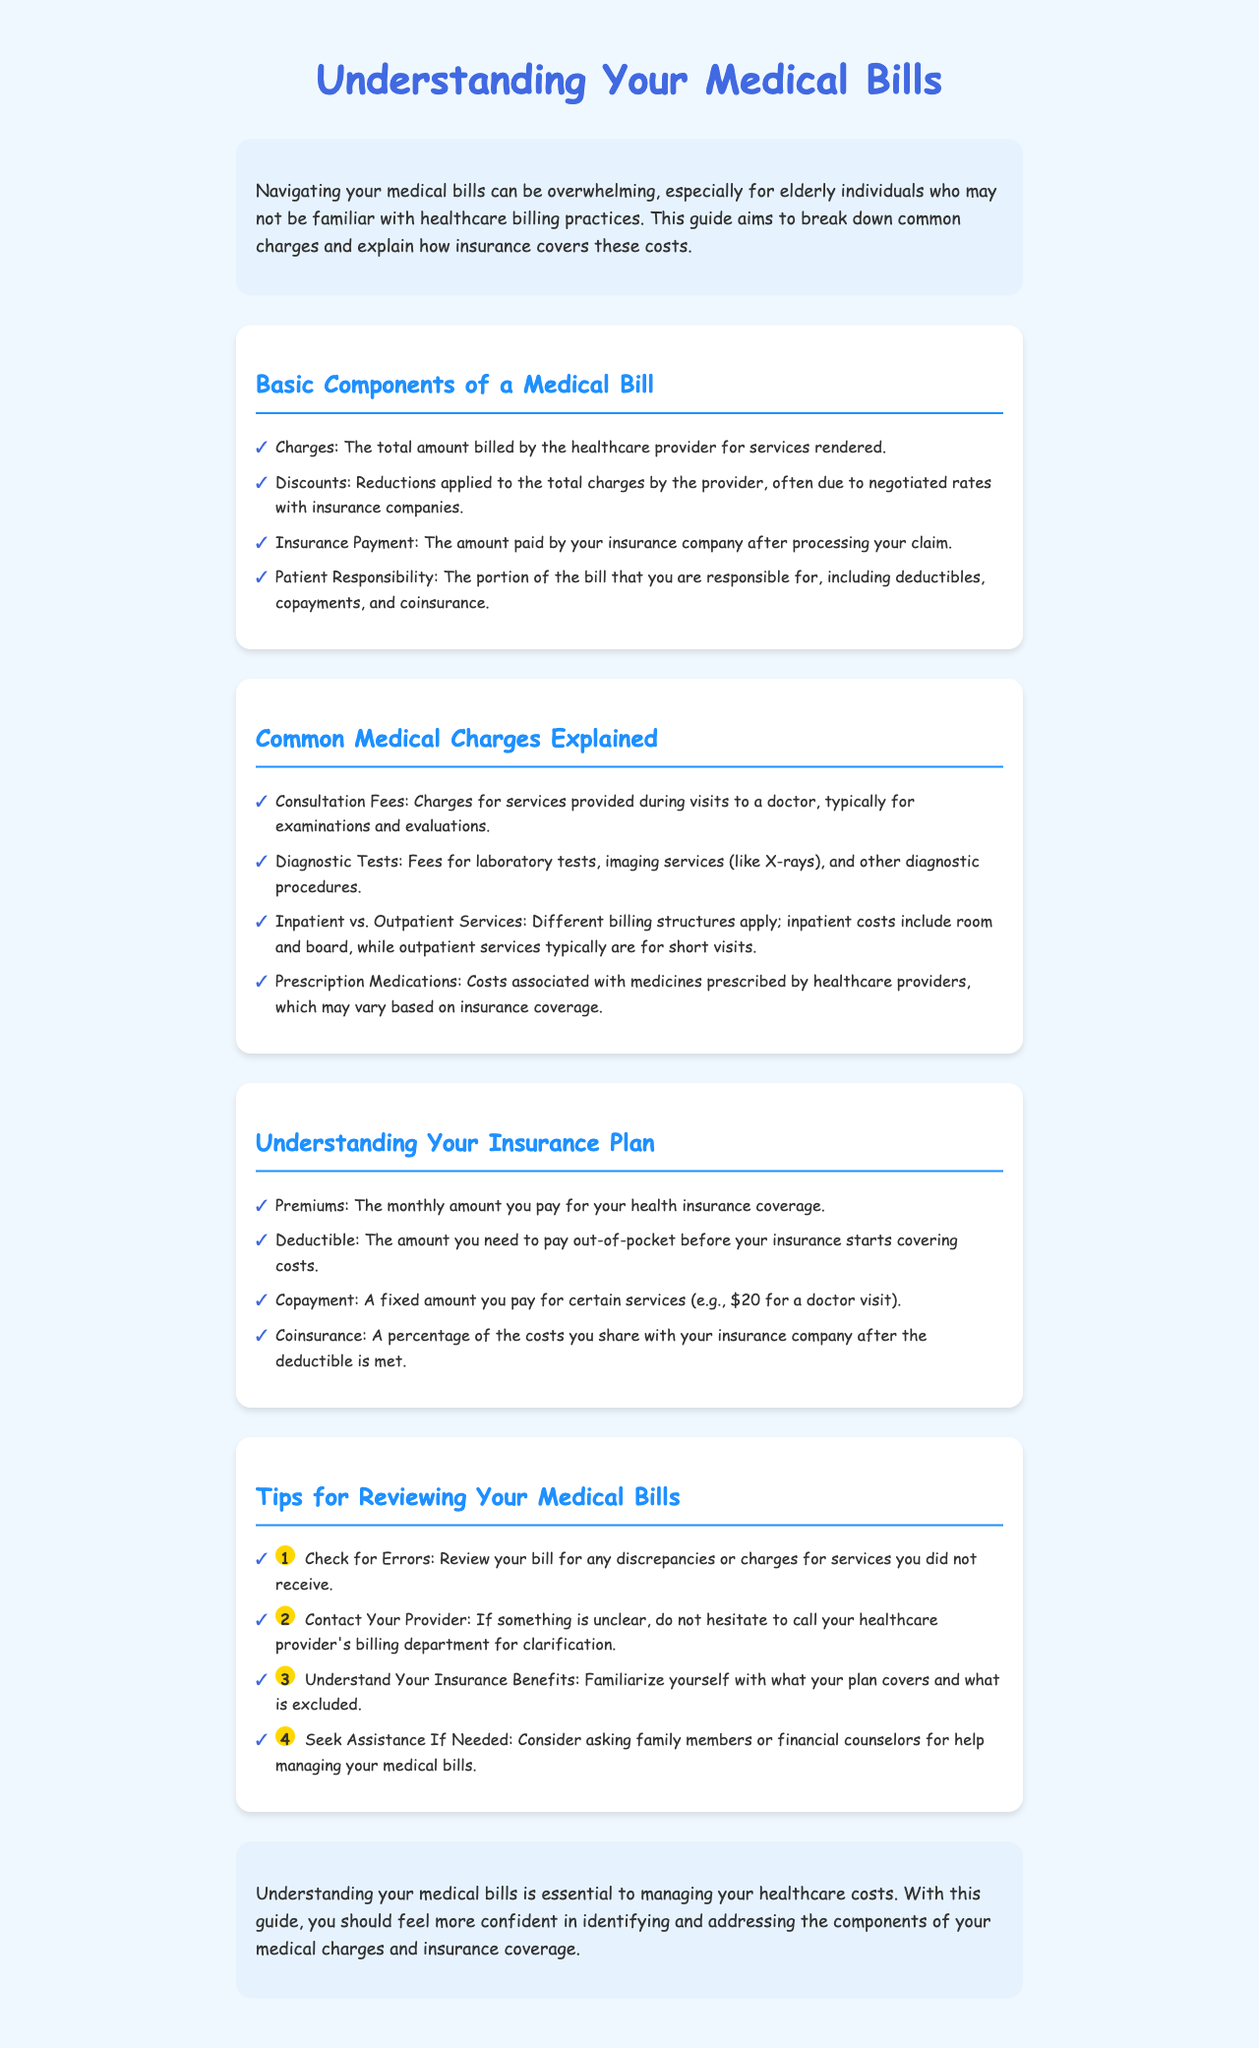What are the basic components of a medical bill? The document lists the basic components as Charges, Discounts, Insurance Payment, and Patient Responsibility.
Answer: Charges, Discounts, Insurance Payment, Patient Responsibility What is a copayment? A copayment is defined in the document as a fixed amount you pay for certain services, like $20 for a doctor visit.
Answer: A fixed amount What are consultation fees? Consultation fees refer to the charges for services provided during visits to a doctor, typically for examinations and evaluations.
Answer: Charges for services What is the purpose of reviewing medical bills? The document suggests reviewing your bills to check for errors and understand your charges, ensuring accuracy and clarity in billing.
Answer: To check for errors What should you do if you find discrepancies in your medical bill? The document advises contacting your provider's billing department for clarification if you find discrepancies.
Answer: Contact your provider What does deductible refer to? A deductible is the amount you need to pay out-of-pocket before your insurance starts covering costs, as defined in the insurance section.
Answer: Amount you pay out-of-pocket How many tips for reviewing your medical bills are provided in the document? The document lists four tips for reviewing your medical bills.
Answer: Four tips What is the background color of the document? The background color of the document is light blue (#f0f8ff) as specified in the style section.
Answer: Light blue What is the main aim of this guide? According to the introduction, the main aim is to help elderly individuals navigate their medical bills and understand charges and insurance coverage.
Answer: To help elderly individuals navigate bills 